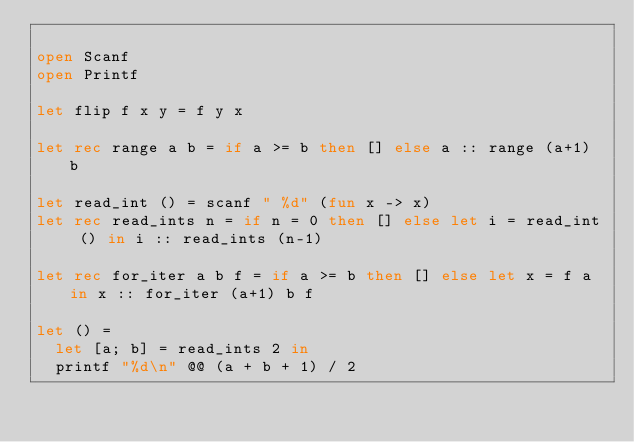Convert code to text. <code><loc_0><loc_0><loc_500><loc_500><_OCaml_>
open Scanf
open Printf

let flip f x y = f y x

let rec range a b = if a >= b then [] else a :: range (a+1) b

let read_int () = scanf " %d" (fun x -> x)
let rec read_ints n = if n = 0 then [] else let i = read_int () in i :: read_ints (n-1)

let rec for_iter a b f = if a >= b then [] else let x = f a in x :: for_iter (a+1) b f

let () =
  let [a; b] = read_ints 2 in
  printf "%d\n" @@ (a + b + 1) / 2
</code> 